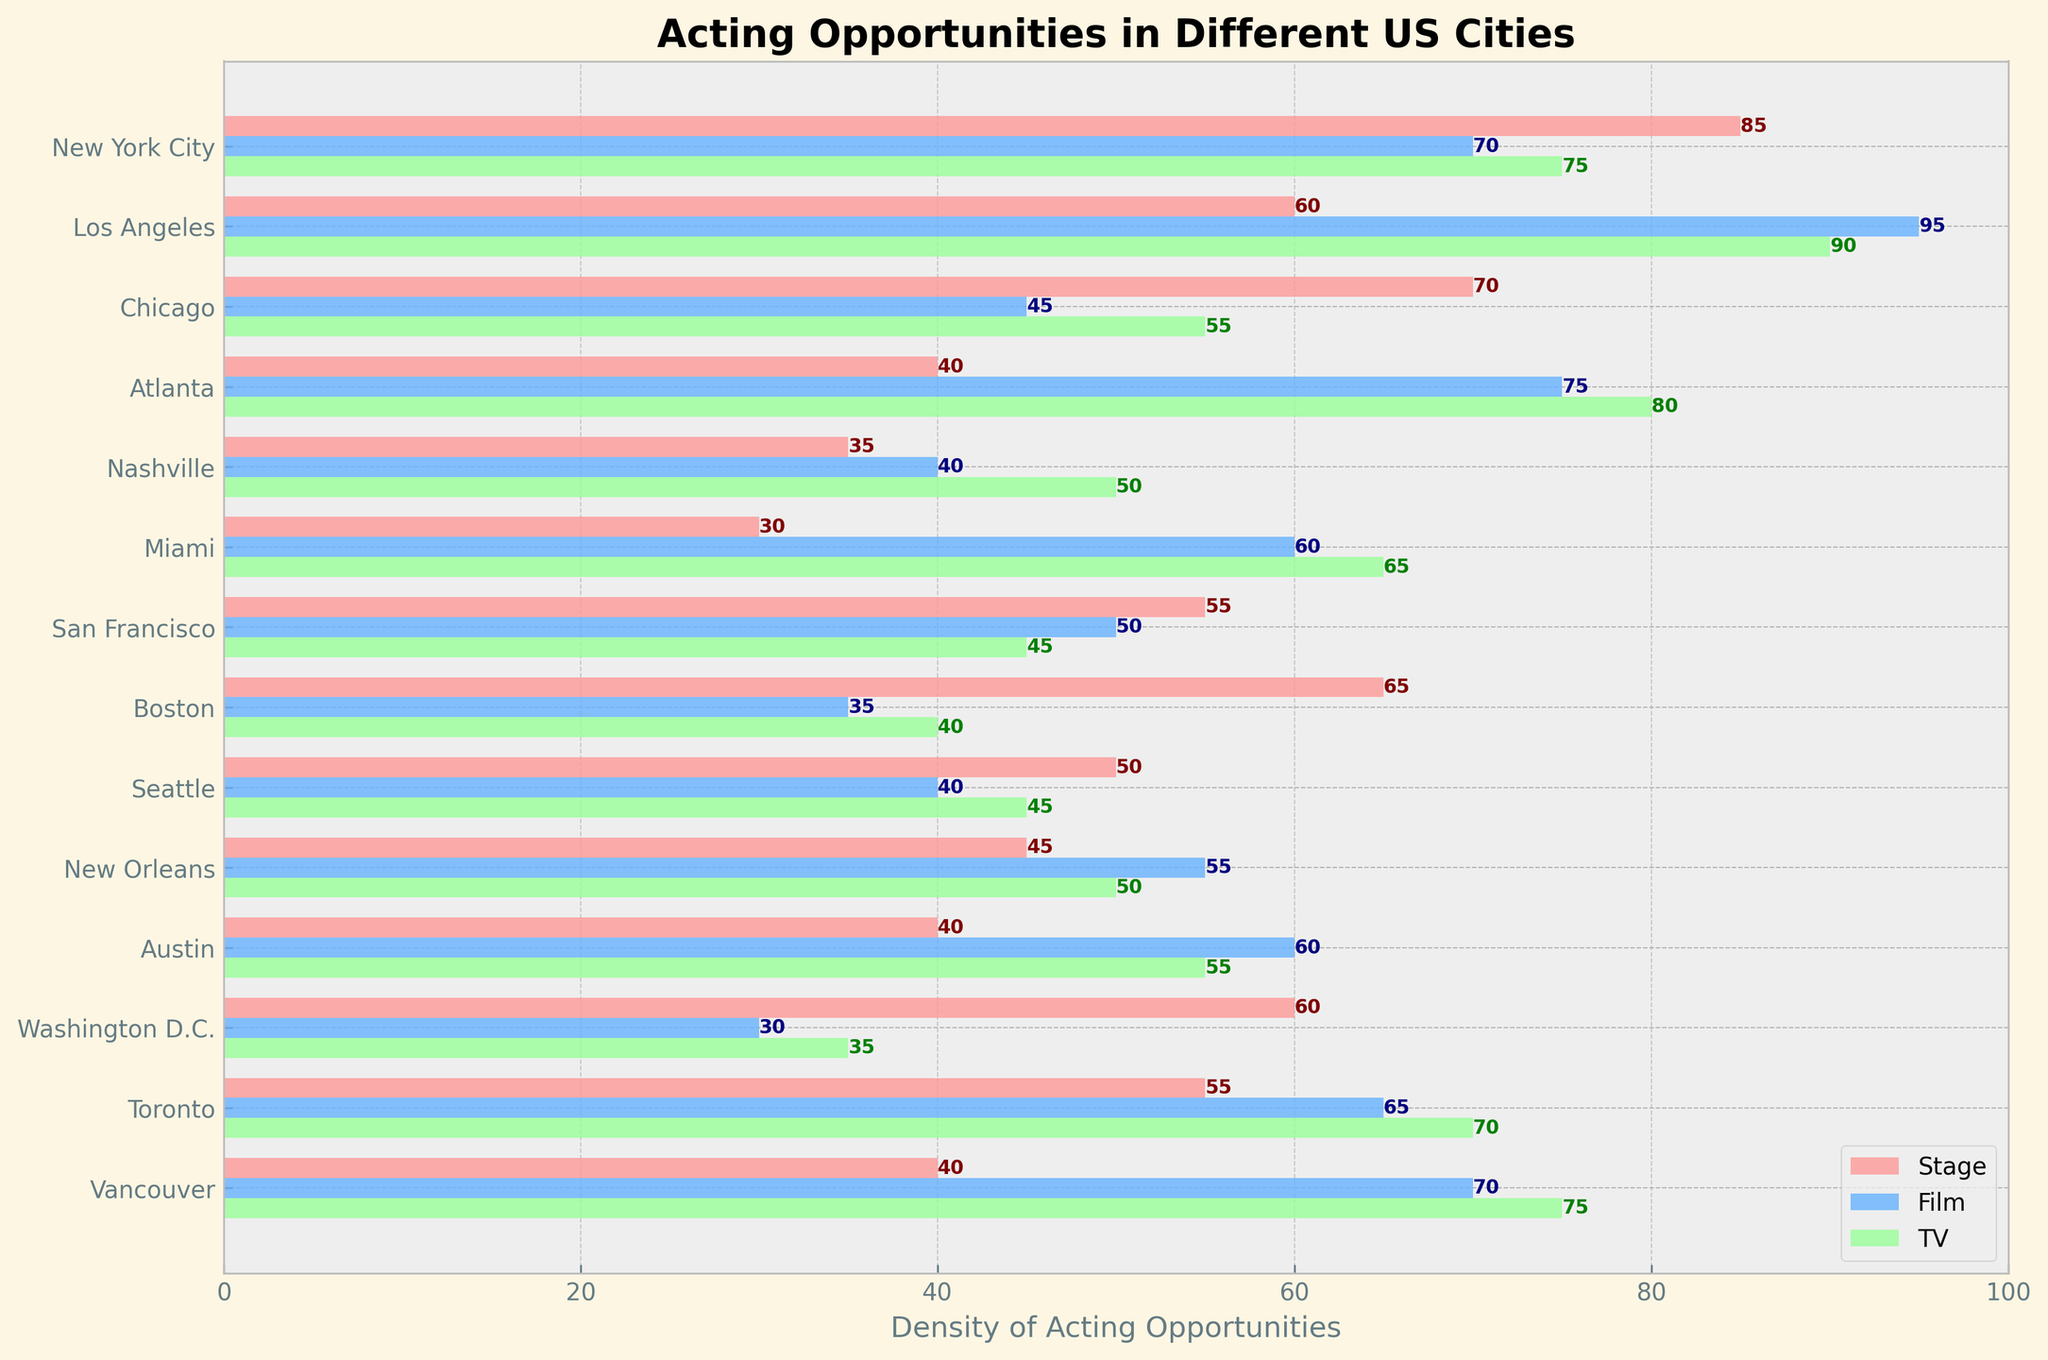What is the title of the plot? The title of the plot is found at the top of the figure.
Answer: Acting Opportunities in Different US Cities Which city has the highest density of stage acting opportunities? By comparing the height of the stage bars (colored in light red) across different cities, the tallest bar signifies the highest density.
Answer: New York City What is the average density of film opportunities in Los Angeles, Atlanta, and Toronto? Sum the densities for these cities (95 + 75 + 65) and divide by the number of cities (3). The sum is 235, so the average is 235/3 = 78.3.
Answer: 78.3 Which city has the smallest range in density between stage, film, and TV opportunities? For each city, calculate the range as the difference between the highest and lowest values among stage, film, and TV. The city with the smallest range has the smallest difference.
Answer: Washington D.C Between New York City and Los Angeles, which has a higher density of TV opportunities? Compare the lengths of the TV bars (colored in light green) for New York City and Los Angeles.
Answer: Los Angeles How many cities have higher density for TV opportunities than stage opportunities? Count the cities where the TV bar (green) is longer than the stage bar (light red).
Answer: 7 What is the combined density of film opportunities in New Orleans and Miami? Add the densities of film opportunities for both cities (55 + 60).
Answer: 115 Which city shows a balanced distribution among stage, film, and TV opportunities? Look for a city where the lengths of the bars for stage, film, and TV are relatively close to each other.
Answer: Vancouver Is there a city where the density of stage opportunities exceeds 80? Check if any stage bar, colored in light red, exceeds the horizontal value of 80.
Answer: Yes, New York City Between Chicago and Boston, which city has more opportunities for stage acting? Compare the lengths of the stage bars (colored in light red) for Chicago and Boston.
Answer: Chicago 